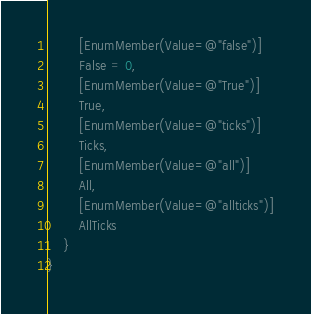<code> <loc_0><loc_0><loc_500><loc_500><_C#_>        [EnumMember(Value=@"false")]
        False = 0,
        [EnumMember(Value=@"True")]
        True,
        [EnumMember(Value=@"ticks")]
        Ticks,
        [EnumMember(Value=@"all")]
        All,
        [EnumMember(Value=@"allticks")]
        AllTicks
    }
}</code> 